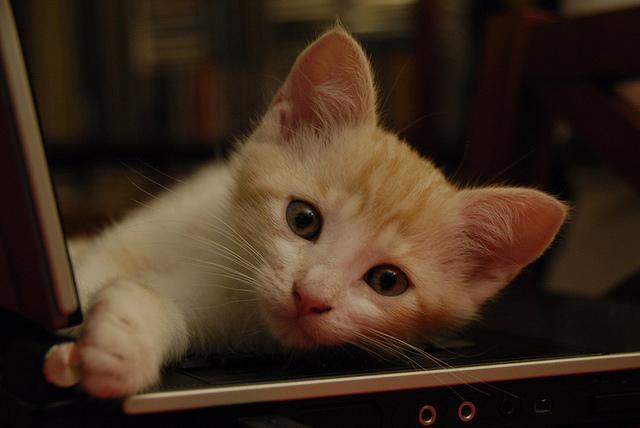How many people can be seen?
Give a very brief answer. 0. 